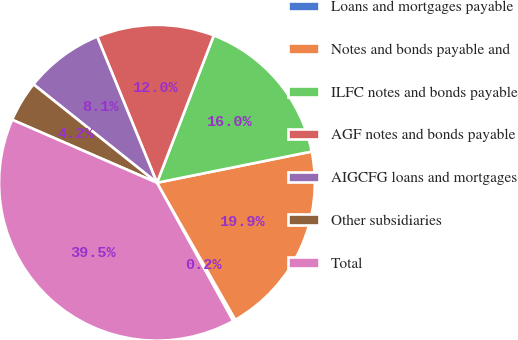<chart> <loc_0><loc_0><loc_500><loc_500><pie_chart><fcel>Loans and mortgages payable<fcel>Notes and bonds payable and<fcel>ILFC notes and bonds payable<fcel>AGF notes and bonds payable<fcel>AIGCFG loans and mortgages<fcel>Other subsidiaries<fcel>Total<nl><fcel>0.25%<fcel>19.9%<fcel>15.97%<fcel>12.04%<fcel>8.11%<fcel>4.18%<fcel>39.55%<nl></chart> 